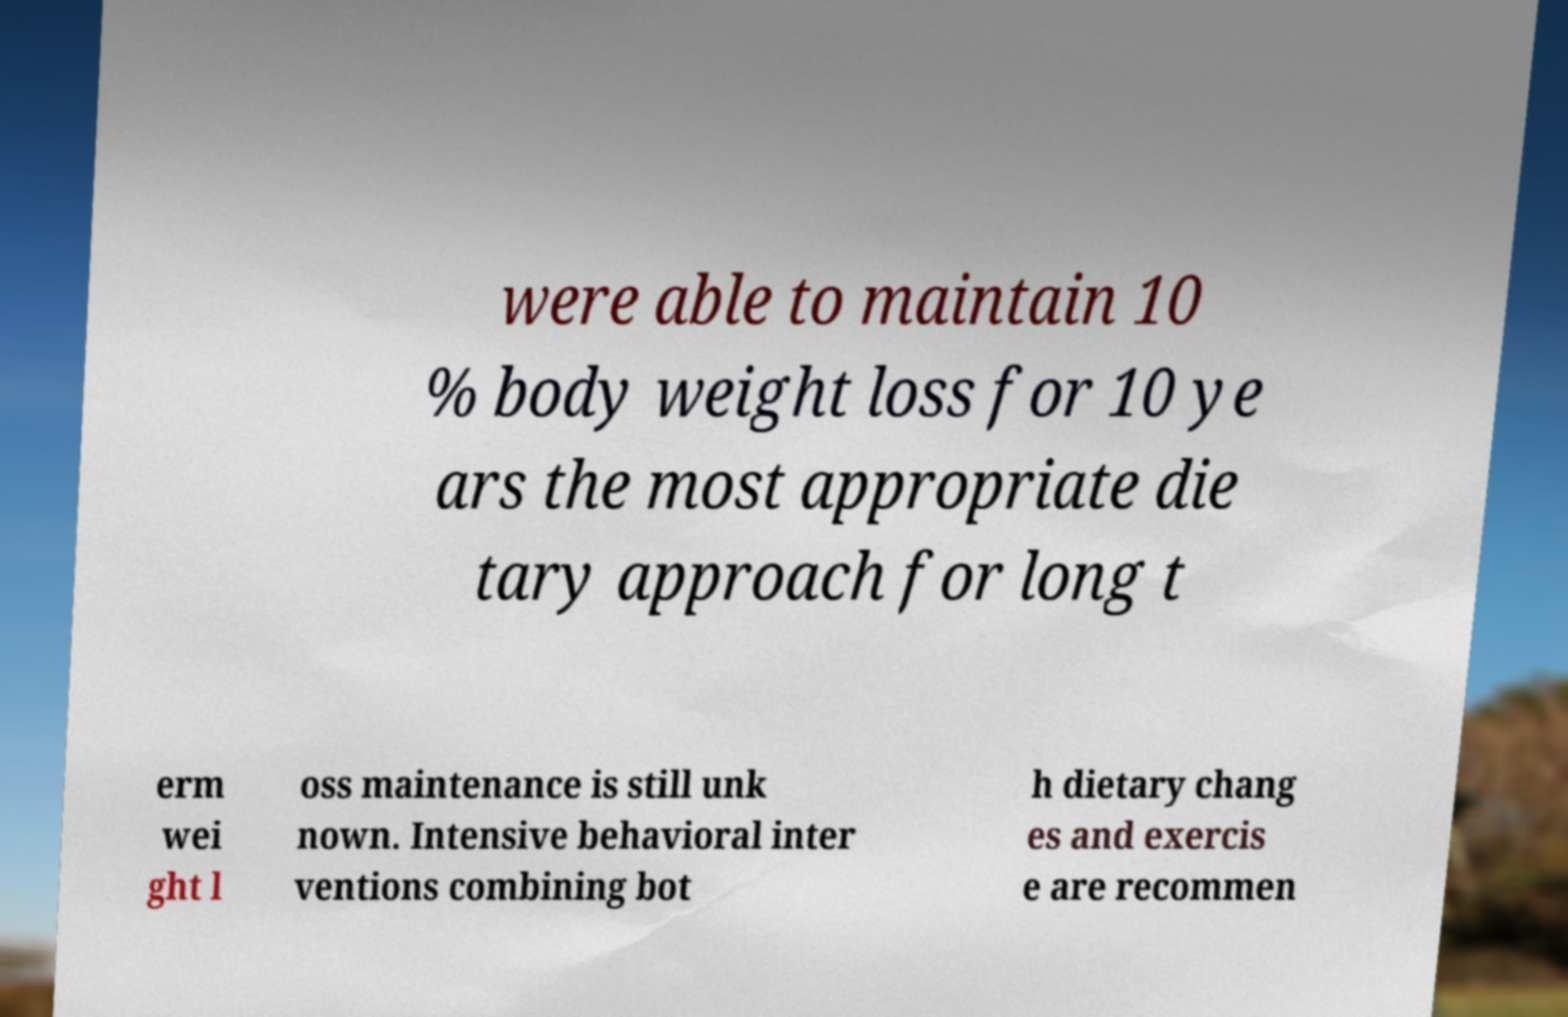Could you extract and type out the text from this image? were able to maintain 10 % body weight loss for 10 ye ars the most appropriate die tary approach for long t erm wei ght l oss maintenance is still unk nown. Intensive behavioral inter ventions combining bot h dietary chang es and exercis e are recommen 